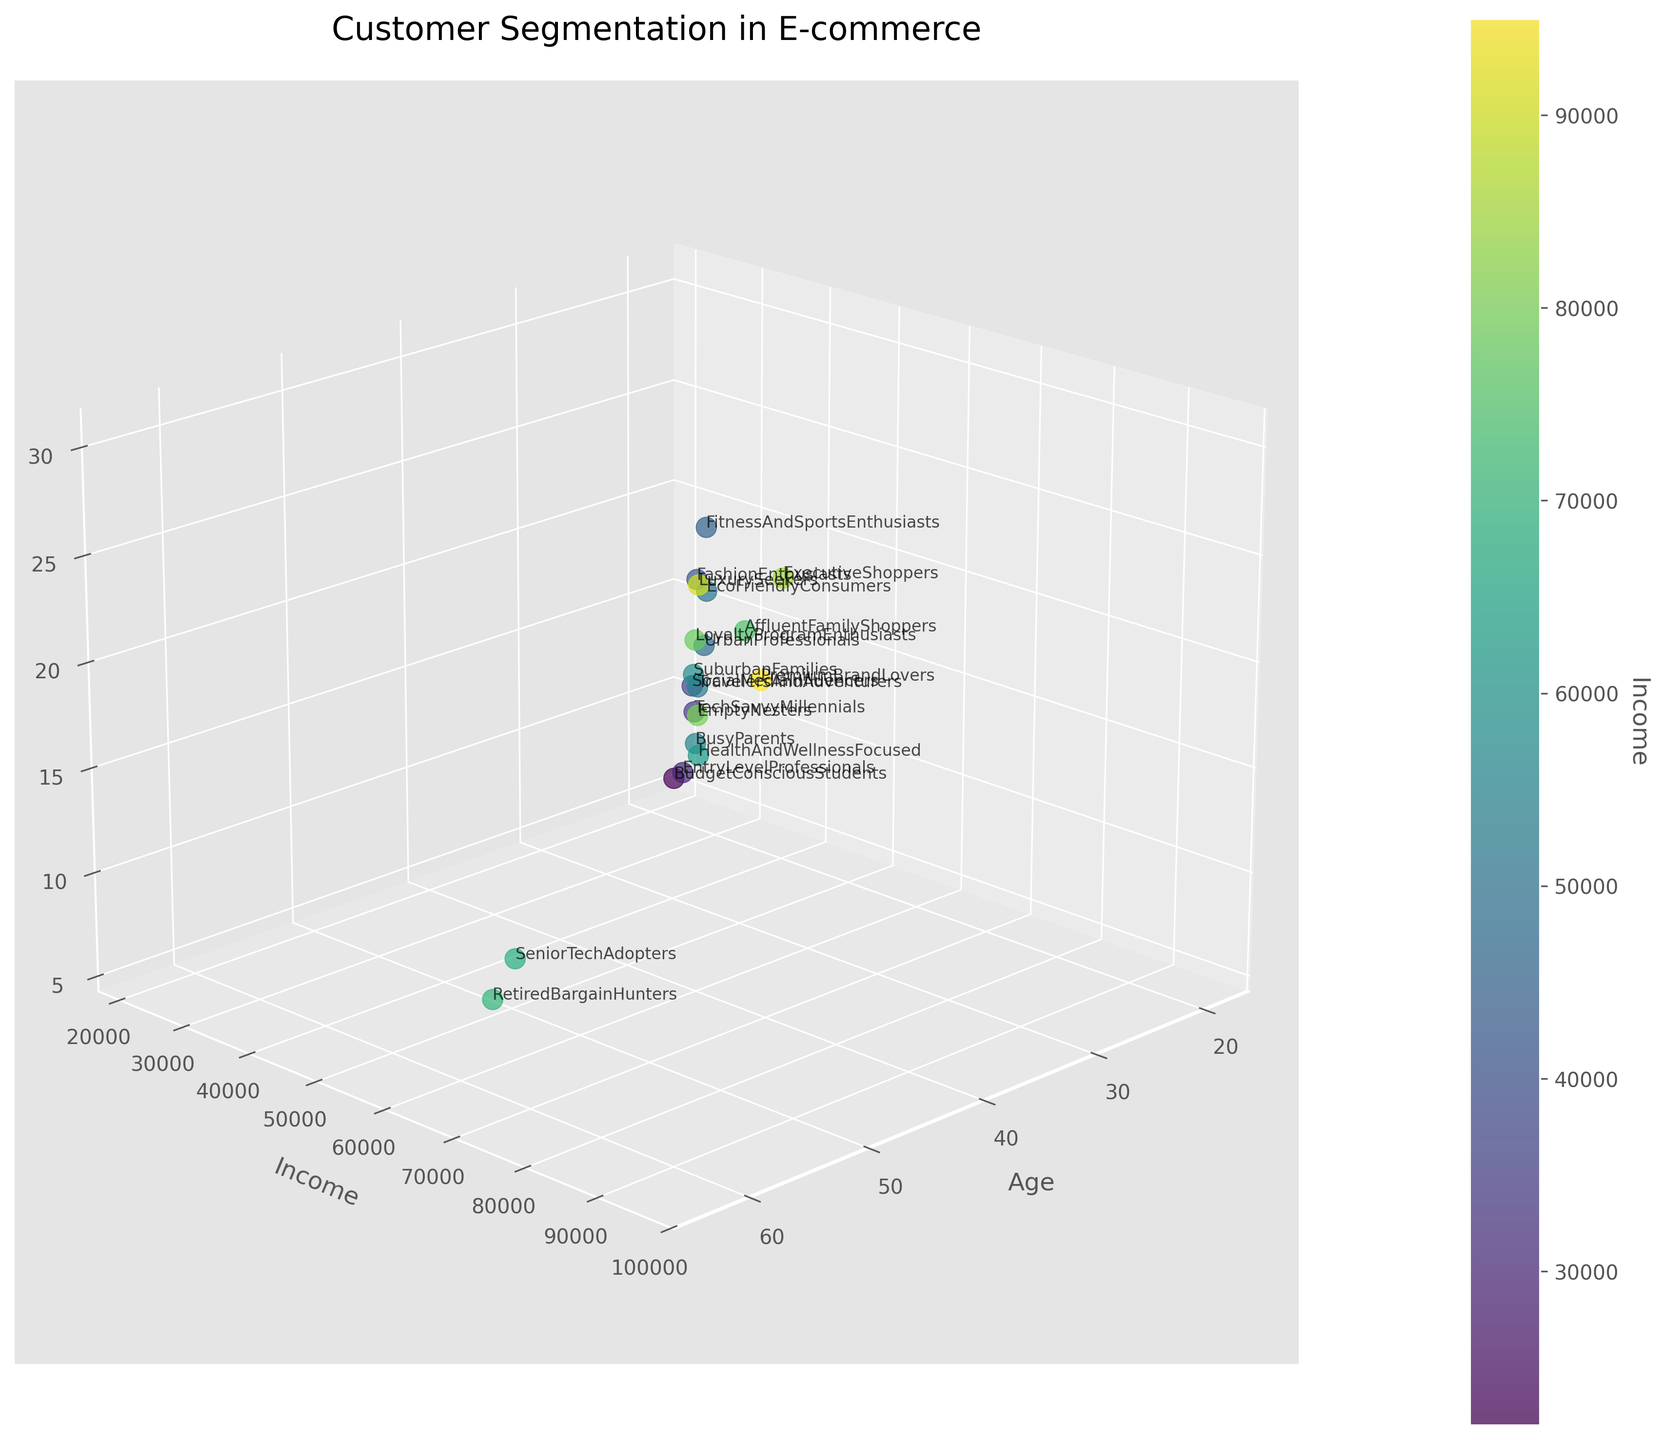What is the title of the figure? The title is displayed prominently at the top center of the figure. It helps to quickly understand the focus of the visualization. In this case, it mentions customer segmentation in e-commerce.
Answer: Customer Segmentation in E-commerce What is the range of ages shown in the scatter plot? By observing the spread of the data points along the x-axis labeled 'Age', you can see the lowest and highest values.
Answer: 19-63 Which customer segment has the highest purchase frequency, and what is their income? By looking at the z-axis labeled 'Purchase Frequency' and identifying the highest point, and then checking the color gradient and annotation, we can find the corresponding segment and income.
Answer: LuxurySeekers, $90,000 What is the average income of the customer segments displayed? By summing up all the income values provided for each customer segment and dividing by the number of segments (20), we can calculate the average income.
Answer: $59,850 How do Tech Savvy Millennials and Budget-Conscious Students compare in terms of purchase frequency? Locate the two customer segments in the scatter plot and compare their positions on the z-axis labeled 'Purchase Frequency'.
Answer: 12 vs. 6 Which segment appears to have the highest income? Identify the segment located at the highest point on the color gradient or closest to the highest income tick on the y-axis labeled 'Income'.
Answer: PremiumBrandLovers Is there a general trend in purchase frequency as income increases? Observe the overall distribution of points in terms of z-axis (Purchase Frequency) and y-axis (Income) to identify any pattern or trend.
Answer: Generally, purchase frequency increases with income What segment falls around an age of 40 with a mid-range income and moderate purchase frequency? Locate the data point around age 40 on the x-axis, with mid-range income on the y-axis, and moderate frequency on the z-axis. Check the segment annotation.
Answer: HealthAndWellnessFocused Who has higher purchase frequency: Busy Parents or Fitness And Sports Enthusiasts? Compare the z-axis values for Busy Parents and Fitness And Sports Enthusiasts.
Answer: Fitness And Sports Enthusiasts Which segments are likely to represent students based on their characteristics? Look for segments with lower age and lower income and moderate purchase frequencies to identify likely student segments.
Answer: BudgetConsciousStudents, EntryLevelProfessionals 